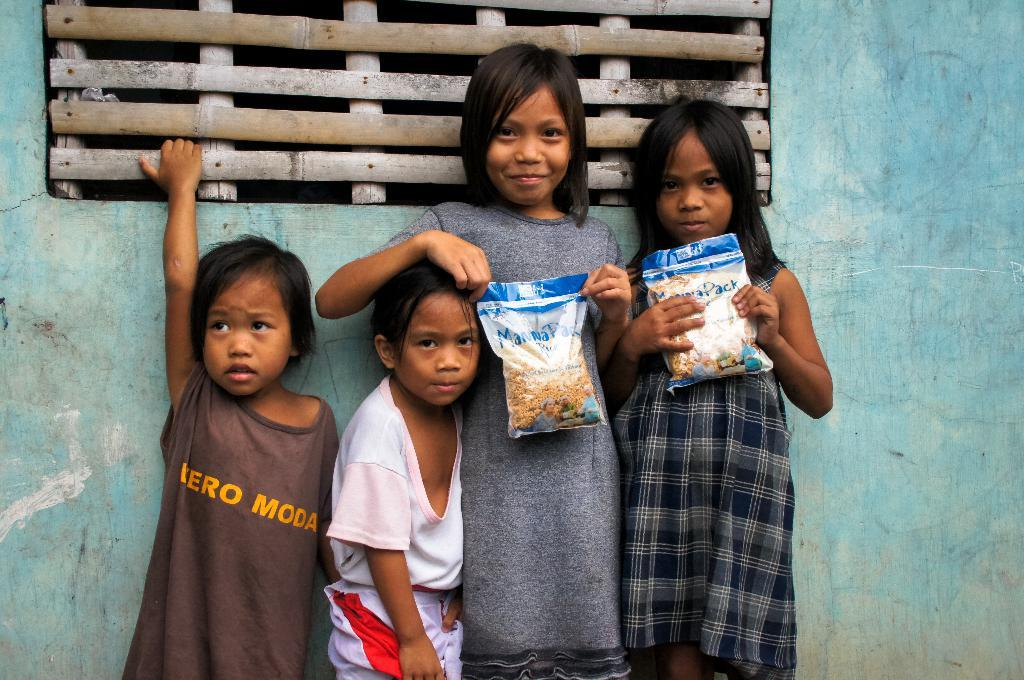How many people are in the image? There are four persons in the image. What are two of the persons doing in the image? Two of the persons are holding objects. What can be seen in the background of the image? There is a wall in the background of the image. What type of object is visible at the top of the image? There is a wooden object visible at the top of the image. What type of cactus can be seen growing on the wall in the image? There is no cactus visible in the image; the background features a wall without any plants. What industry is depicted in the image? The image does not depict any specific industry; it features four persons and a wooden object. 